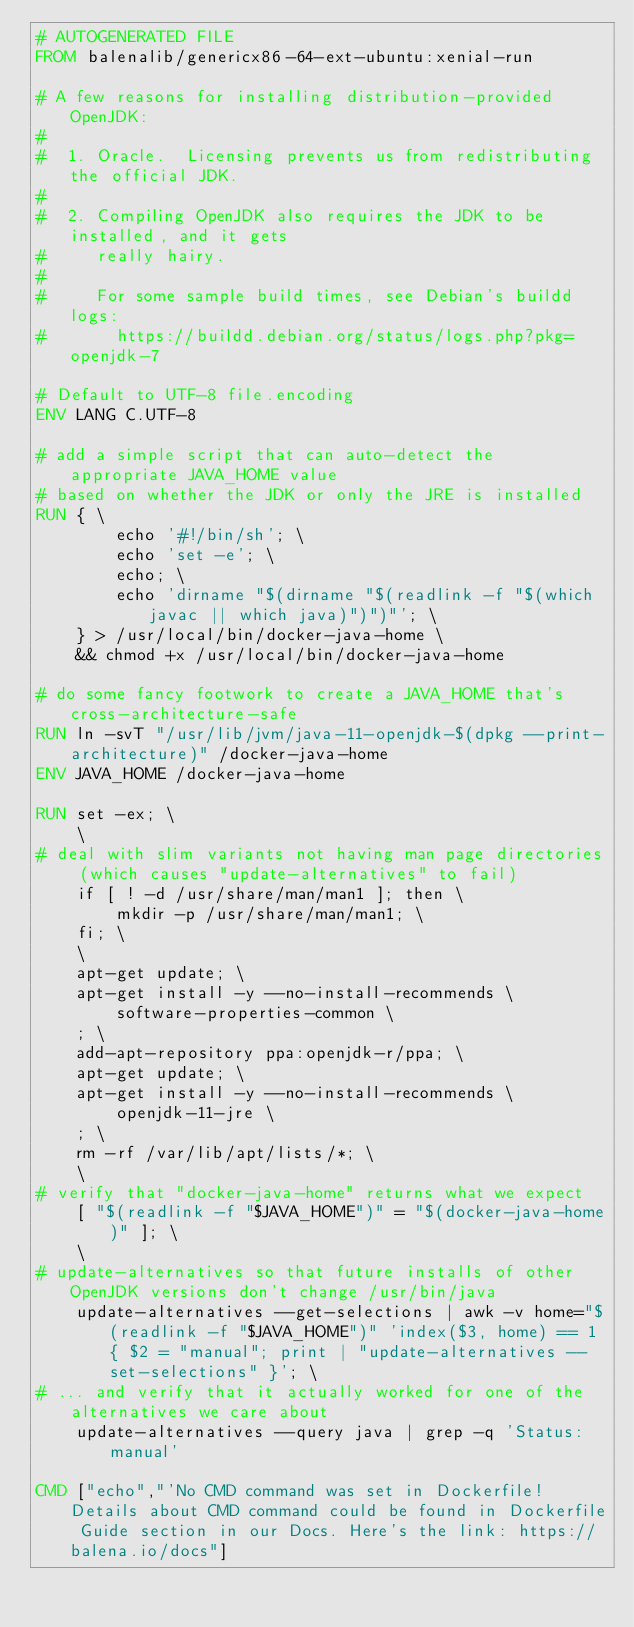<code> <loc_0><loc_0><loc_500><loc_500><_Dockerfile_># AUTOGENERATED FILE
FROM balenalib/genericx86-64-ext-ubuntu:xenial-run

# A few reasons for installing distribution-provided OpenJDK:
#
#  1. Oracle.  Licensing prevents us from redistributing the official JDK.
#
#  2. Compiling OpenJDK also requires the JDK to be installed, and it gets
#     really hairy.
#
#     For some sample build times, see Debian's buildd logs:
#       https://buildd.debian.org/status/logs.php?pkg=openjdk-7

# Default to UTF-8 file.encoding
ENV LANG C.UTF-8

# add a simple script that can auto-detect the appropriate JAVA_HOME value
# based on whether the JDK or only the JRE is installed
RUN { \
		echo '#!/bin/sh'; \
		echo 'set -e'; \
		echo; \
		echo 'dirname "$(dirname "$(readlink -f "$(which javac || which java)")")"'; \
	} > /usr/local/bin/docker-java-home \
	&& chmod +x /usr/local/bin/docker-java-home

# do some fancy footwork to create a JAVA_HOME that's cross-architecture-safe
RUN ln -svT "/usr/lib/jvm/java-11-openjdk-$(dpkg --print-architecture)" /docker-java-home
ENV JAVA_HOME /docker-java-home

RUN set -ex; \
	\
# deal with slim variants not having man page directories (which causes "update-alternatives" to fail)
	if [ ! -d /usr/share/man/man1 ]; then \
		mkdir -p /usr/share/man/man1; \
	fi; \
	\
	apt-get update; \
	apt-get install -y --no-install-recommends \
		software-properties-common \
	; \
	add-apt-repository ppa:openjdk-r/ppa; \
	apt-get update; \
	apt-get install -y --no-install-recommends \
		openjdk-11-jre \
	; \
	rm -rf /var/lib/apt/lists/*; \
	\
# verify that "docker-java-home" returns what we expect
	[ "$(readlink -f "$JAVA_HOME")" = "$(docker-java-home)" ]; \
	\
# update-alternatives so that future installs of other OpenJDK versions don't change /usr/bin/java
	update-alternatives --get-selections | awk -v home="$(readlink -f "$JAVA_HOME")" 'index($3, home) == 1 { $2 = "manual"; print | "update-alternatives --set-selections" }'; \
# ... and verify that it actually worked for one of the alternatives we care about
	update-alternatives --query java | grep -q 'Status: manual'

CMD ["echo","'No CMD command was set in Dockerfile! Details about CMD command could be found in Dockerfile Guide section in our Docs. Here's the link: https://balena.io/docs"]
</code> 